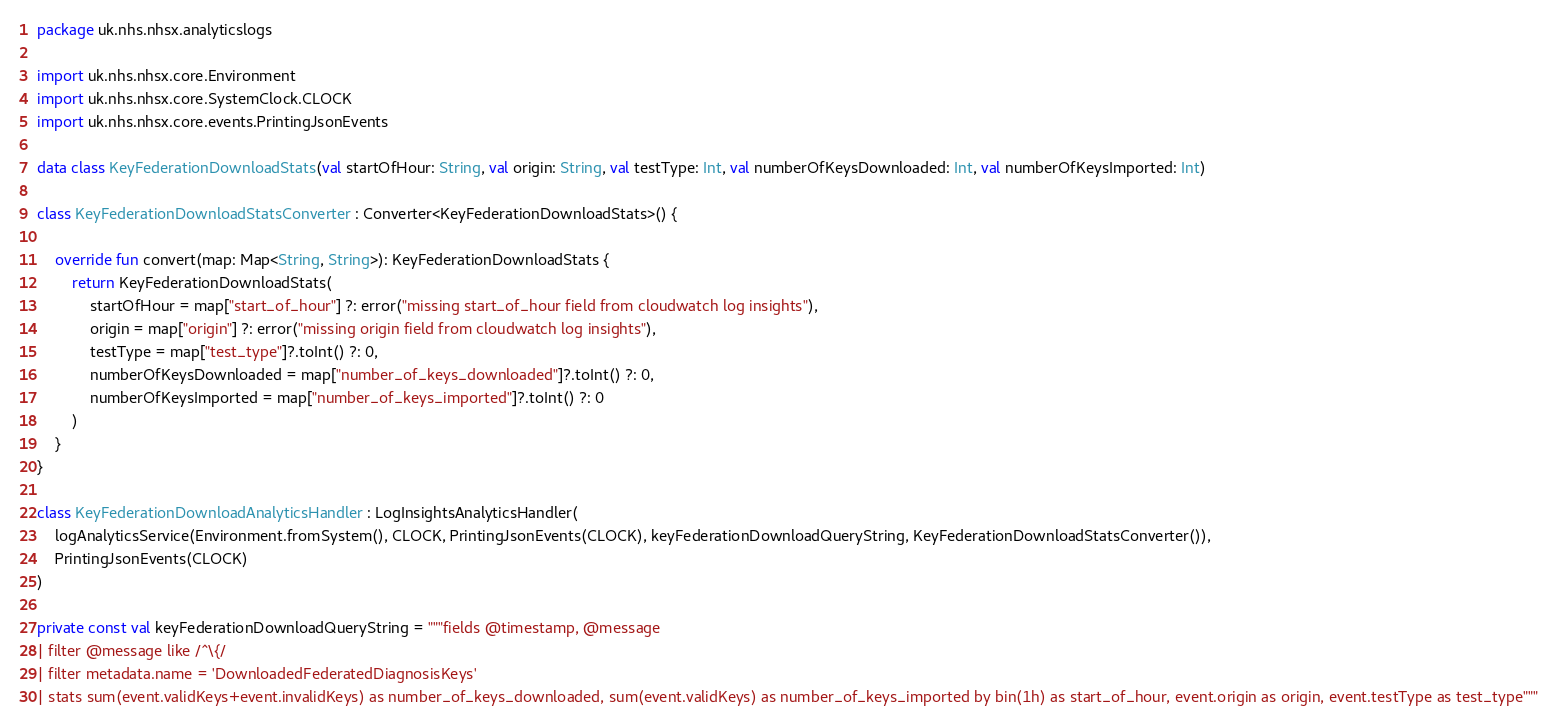Convert code to text. <code><loc_0><loc_0><loc_500><loc_500><_Kotlin_>package uk.nhs.nhsx.analyticslogs

import uk.nhs.nhsx.core.Environment
import uk.nhs.nhsx.core.SystemClock.CLOCK
import uk.nhs.nhsx.core.events.PrintingJsonEvents

data class KeyFederationDownloadStats(val startOfHour: String, val origin: String, val testType: Int, val numberOfKeysDownloaded: Int, val numberOfKeysImported: Int)

class KeyFederationDownloadStatsConverter : Converter<KeyFederationDownloadStats>() {

    override fun convert(map: Map<String, String>): KeyFederationDownloadStats {
        return KeyFederationDownloadStats(
            startOfHour = map["start_of_hour"] ?: error("missing start_of_hour field from cloudwatch log insights"),
            origin = map["origin"] ?: error("missing origin field from cloudwatch log insights"),
            testType = map["test_type"]?.toInt() ?: 0,
            numberOfKeysDownloaded = map["number_of_keys_downloaded"]?.toInt() ?: 0,
            numberOfKeysImported = map["number_of_keys_imported"]?.toInt() ?: 0
        )
    }
}

class KeyFederationDownloadAnalyticsHandler : LogInsightsAnalyticsHandler(
    logAnalyticsService(Environment.fromSystem(), CLOCK, PrintingJsonEvents(CLOCK), keyFederationDownloadQueryString, KeyFederationDownloadStatsConverter()),
    PrintingJsonEvents(CLOCK)
)

private const val keyFederationDownloadQueryString = """fields @timestamp, @message
| filter @message like /^\{/
| filter metadata.name = 'DownloadedFederatedDiagnosisKeys'
| stats sum(event.validKeys+event.invalidKeys) as number_of_keys_downloaded, sum(event.validKeys) as number_of_keys_imported by bin(1h) as start_of_hour, event.origin as origin, event.testType as test_type"""

</code> 